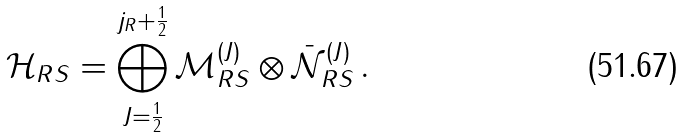Convert formula to latex. <formula><loc_0><loc_0><loc_500><loc_500>\mathcal { H } _ { R S } = \bigoplus _ { J = \frac { 1 } { 2 } } ^ { j _ { R } + \frac { 1 } { 2 } } \mathcal { M } ^ { ( J ) } _ { R S } \otimes \bar { \mathcal { N } } ^ { ( J ) } _ { R S } \, .</formula> 